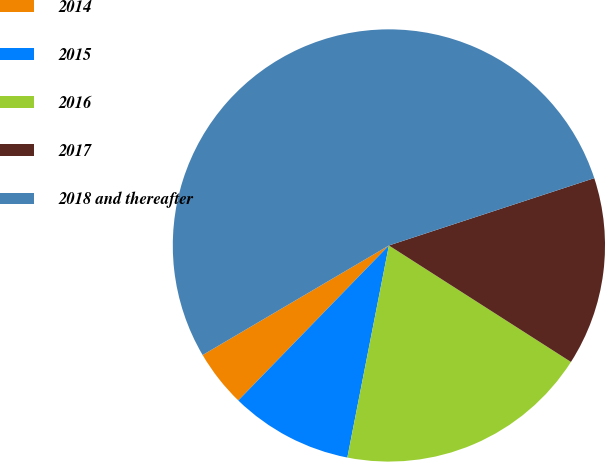Convert chart to OTSL. <chart><loc_0><loc_0><loc_500><loc_500><pie_chart><fcel>2014<fcel>2015<fcel>2016<fcel>2017<fcel>2018 and thereafter<nl><fcel>4.27%<fcel>9.19%<fcel>19.02%<fcel>14.1%<fcel>53.42%<nl></chart> 